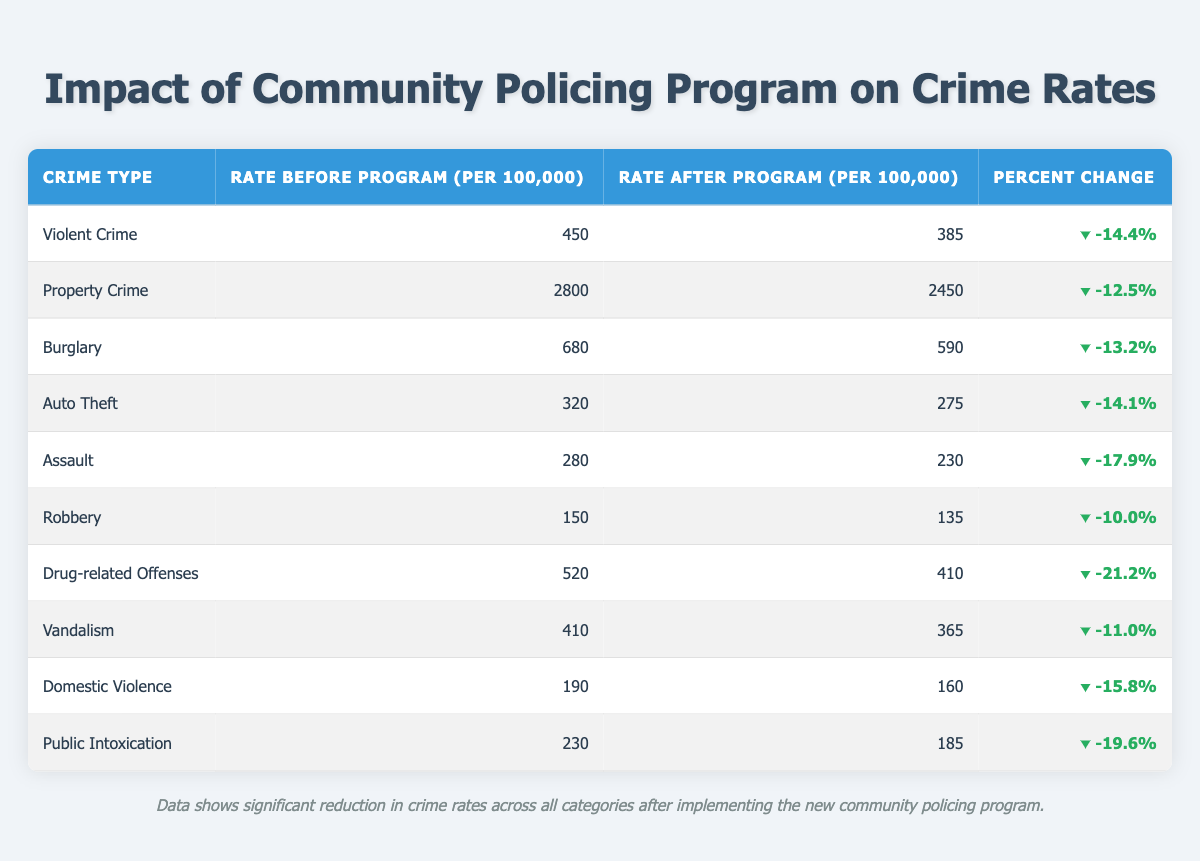What was the rate of Violent Crime before the program? Looking at the row for Violent Crime in the table, the rate before the program is directly stated as 450 per 100,000.
Answer: 450 What is the percent change in Property Crime after implementing the program? The table shows a 12.5% decrease in the rate of Property Crime after the program was implemented.
Answer: -12.5% How many total crime types show a decrease greater than 15%? By examining the Percent Change column, the crime types that show a decrease greater than 15% are Violent Crime, Domestic Violence, Drug-related Offenses, Auto Theft, and Assault. Five crime types meet this criterion.
Answer: 5 Is the rate of Robbery higher before the program compared to after? Yes, the table indicates the rate of Robbery was 150 before the program and is now 135, which means it is higher before the program.
Answer: Yes What is the average rate of Domestic Violence and Public Intoxication after the program? To find the average, first add the rates after the program: 160 (Domestic Violence) + 185 (Public Intoxication) = 345. Then, divide by 2 (the number of rates): 345 / 2 = 172.5.
Answer: 172.5 Which crime type had the highest percent change? Looking through the Percent Change column, Drug-related Offenses had the highest decrease, with a change of -21.2%.
Answer: Drug-related Offenses What is the rate difference between Burglary and Auto Theft after the program? After the program, Burglary's rate is 590 and Auto Theft's rate is 275. The difference is calculated by subtracting the rate of Auto Theft from the rate of Burglary: 590 - 275 = 315.
Answer: 315 Did the implementation of the program reduce all crime rates listed in the table? Yes, all crime types listed in the table show a reduction in rates after the program, as evidenced by the negative percent changes for each category.
Answer: Yes 